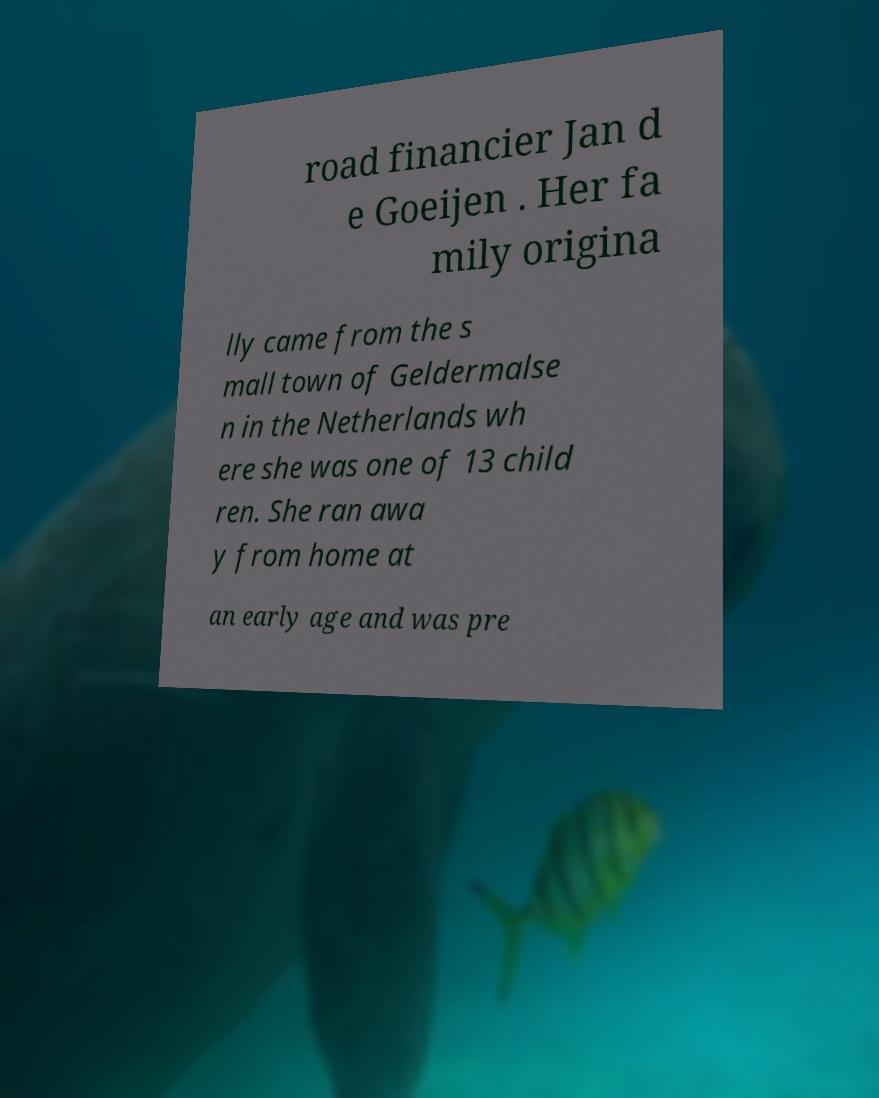Please read and relay the text visible in this image. What does it say? road financier Jan d e Goeijen . Her fa mily origina lly came from the s mall town of Geldermalse n in the Netherlands wh ere she was one of 13 child ren. She ran awa y from home at an early age and was pre 